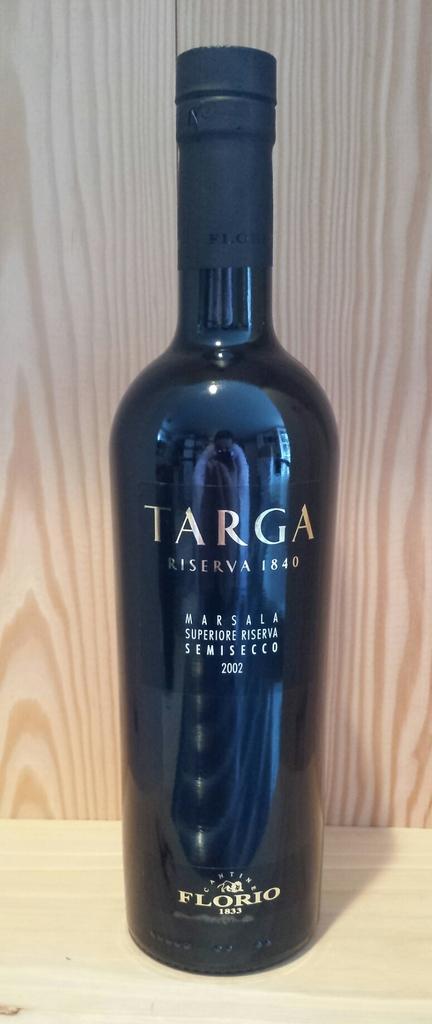What company makes this drink?
Offer a terse response. Targa. 